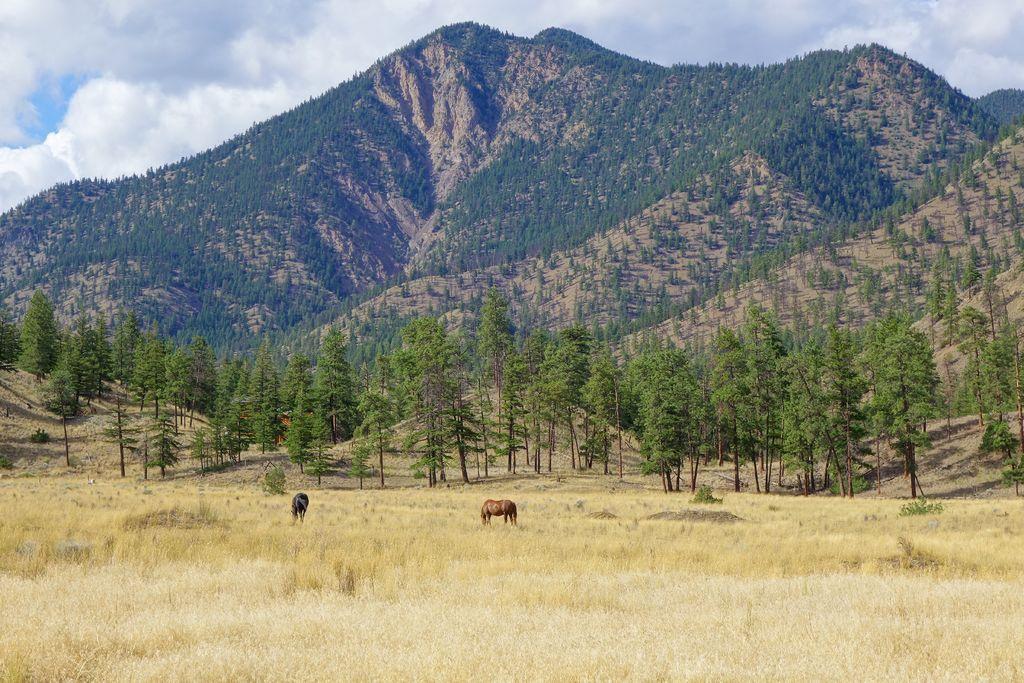Could you give a brief overview of what you see in this image? In this image we can see some animals and in the background of the image there are some trees, mountains and top of the image there is cloudy sky. 